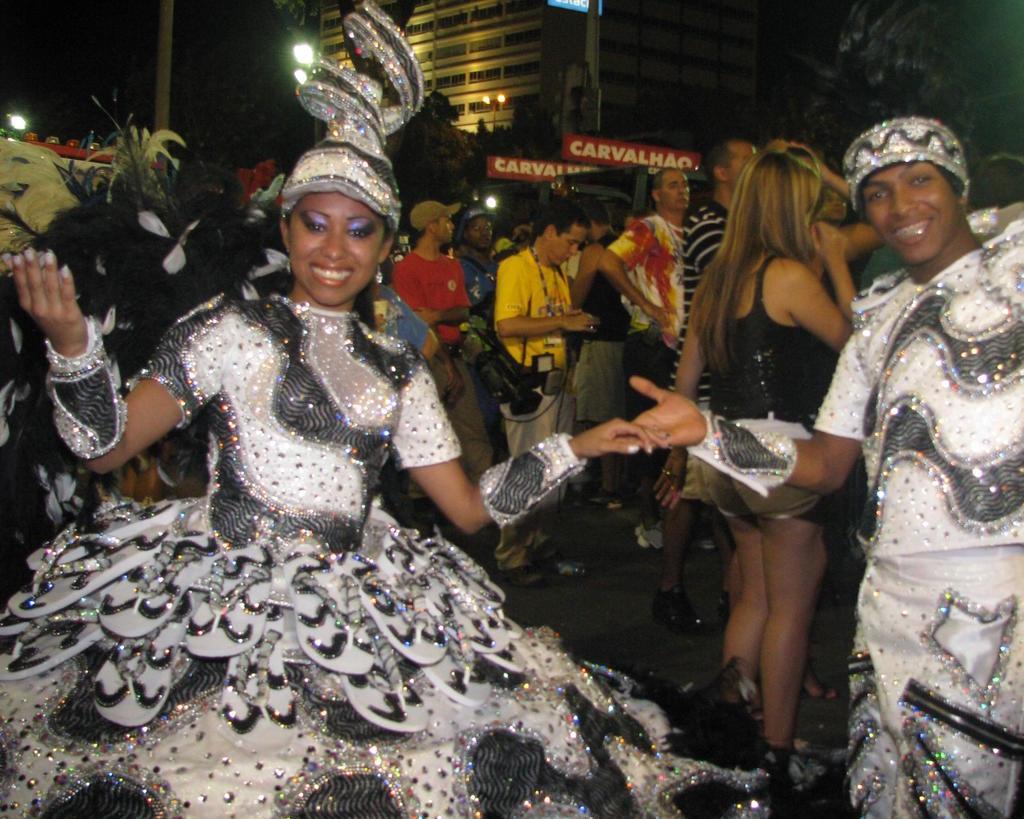Please provide a concise description of this image. In this image, we can see two persons wearing fancy dresses. There are some persons in the middle of the image standing and wearing clothes. There is a building at the top of the image. 